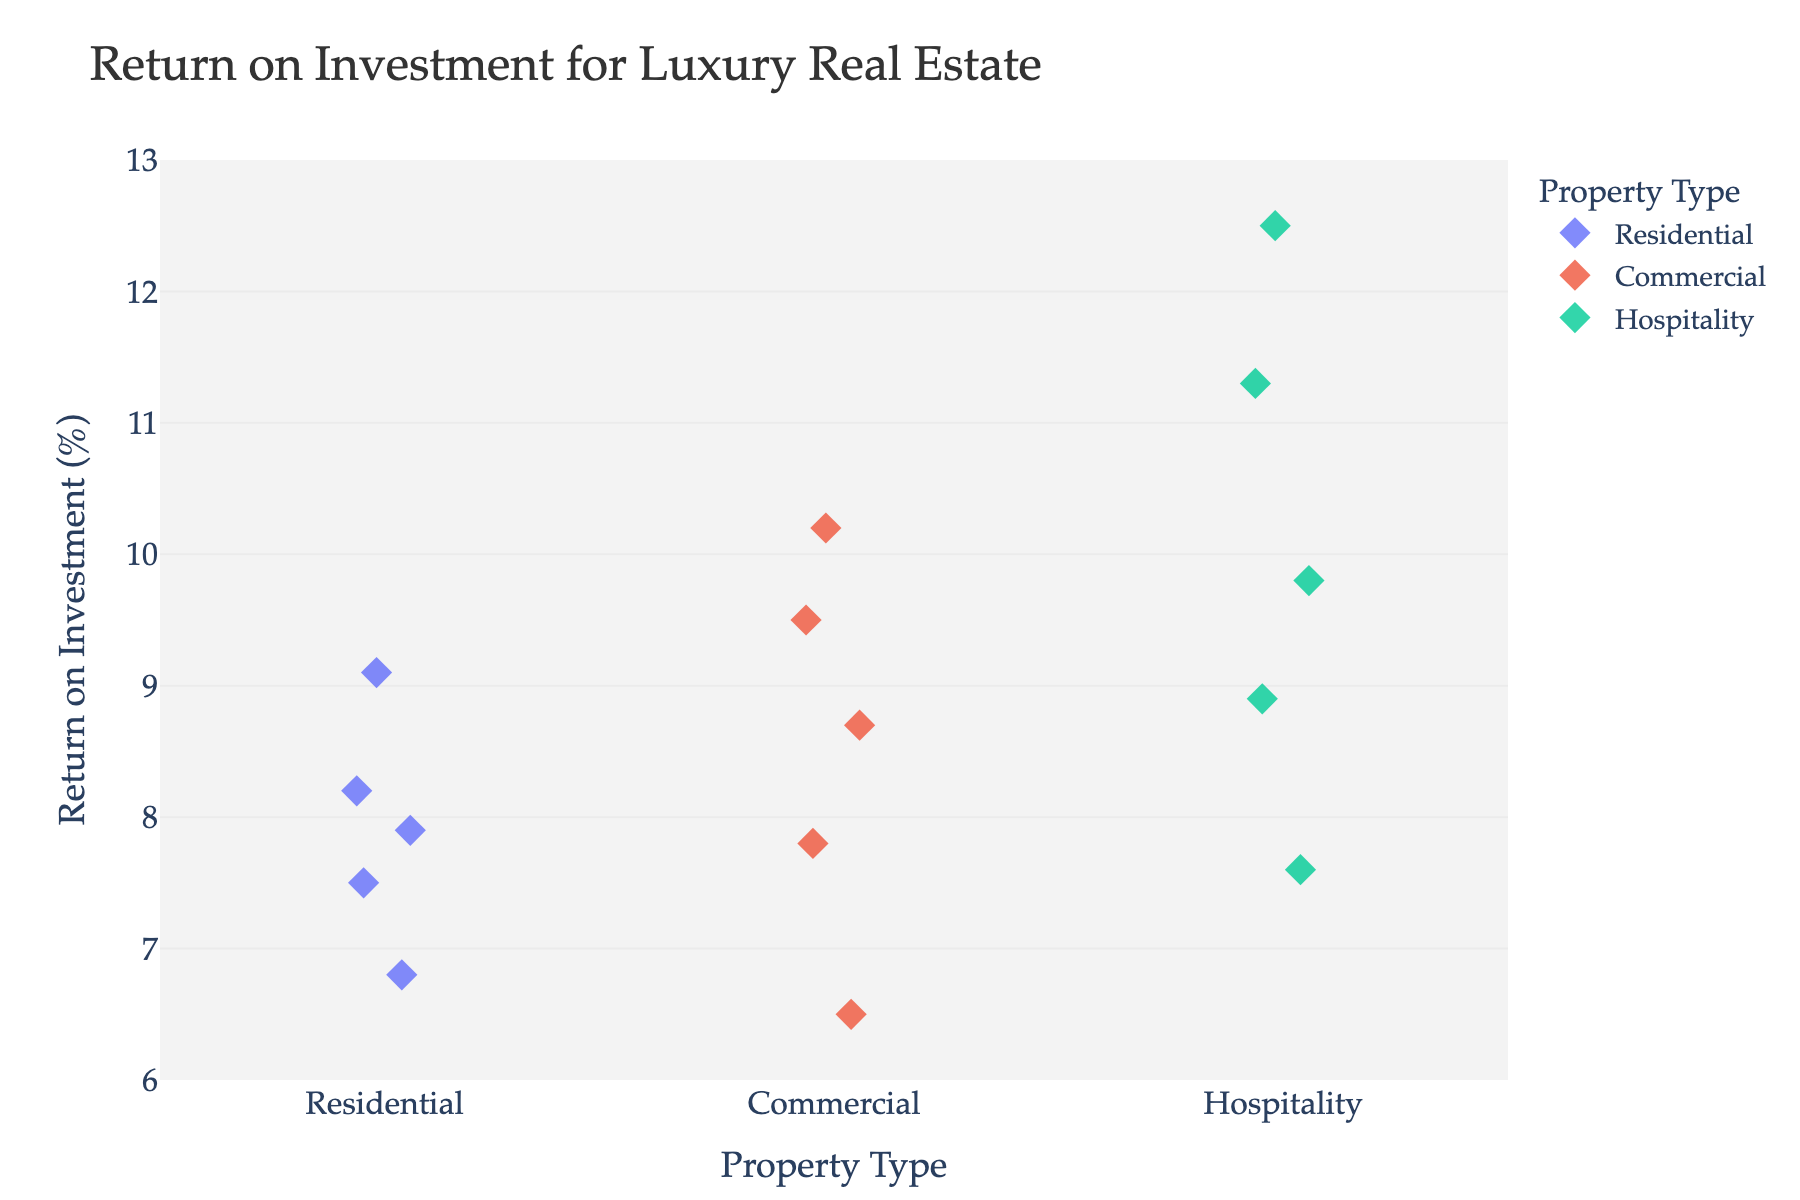What's the title of the plot? The title is generally displayed at the top of the plot and provides a brief overview of what the plot is about. The title here is "Return on Investment for Luxury Real Estate".
Answer: Return on Investment for Luxury Real Estate What types of luxury real estate are shown in the plot? By examining the x-axis of the strip plot, you can see it is divided into three categories: Residential, Commercial, and Hospitality.
Answer: Residential, Commercial, Hospitality Which property has the highest ROI? Look for the data point that reaches the highest point on the y-axis. The Bali Private Island Resort, under the Hospitality category, has the highest ROI of 12.5%.
Answer: Bali Private Island Resort What's the ROI range for Residential properties? Identify the highest and lowest ROI values within the Residential category. The highest ROI for Residential properties is 9.1% for Malibu Beachfront Villa, and the lowest is 6.8% for Aspen Ski Chalet, giving a range of 6.8% to 9.1%.
Answer: 6.8% to 9.1% How many Commercial properties have an ROI above 8%? Count the number of data points in the Commercial category that are positioned above the 8% mark on the y-axis. There are three such properties: Miami Retail Complex, Silicon Valley Tech Campus, and Dubai Mixed-Use Development.
Answer: 3 What is the average ROI for Hospitality properties? Sum the ROI values for all Hospitality properties and then divide by the number of properties in this category. The values are 11.3, 8.9, 12.5, 7.6, and 9.8. The calculation is (11.3 + 8.9 + 12.5 + 7.6 + 9.8) / 5 = 10.02%.
Answer: 10.02% Which type of property generally offers higher ROI, Residential or Commercial? Compare the general placement of data points on the y-axis between Residential and Commercial properties. Commercial properties have more data points with higher ROI values (e.g., Silicon Valley Tech Campus at 10.2% and Dubai Mixed-Use Development at 9.5%) compared to Residential properties.
Answer: Commercial What is the difference in ROI between the property with the highest ROI and the property with the lowest ROI? Identify the maximum and minimum ROI values in the plot, which are 12.5% (Bali Private Island Resort) and 6.5% (London Office Tower). The difference is 12.5% - 6.5% = 6%.
Answer: 6% Do Residential properties generally have a wider range of ROI values compared to Hospitality properties? Calculate the range (difference between max and min values) for both categories: Residential (9.1% - 6.8% = 2.3%), Hospitality (12.5% - 7.6% = 4.9%). The range for Hospitality is wider.
Answer: No Which Hospitality property has the lowest ROI? Among the data points in the Hospitality category, the Parisian Boutique Hotel has the lowest ROI value, which is 7.6%.
Answer: Parisian Boutique Hotel 